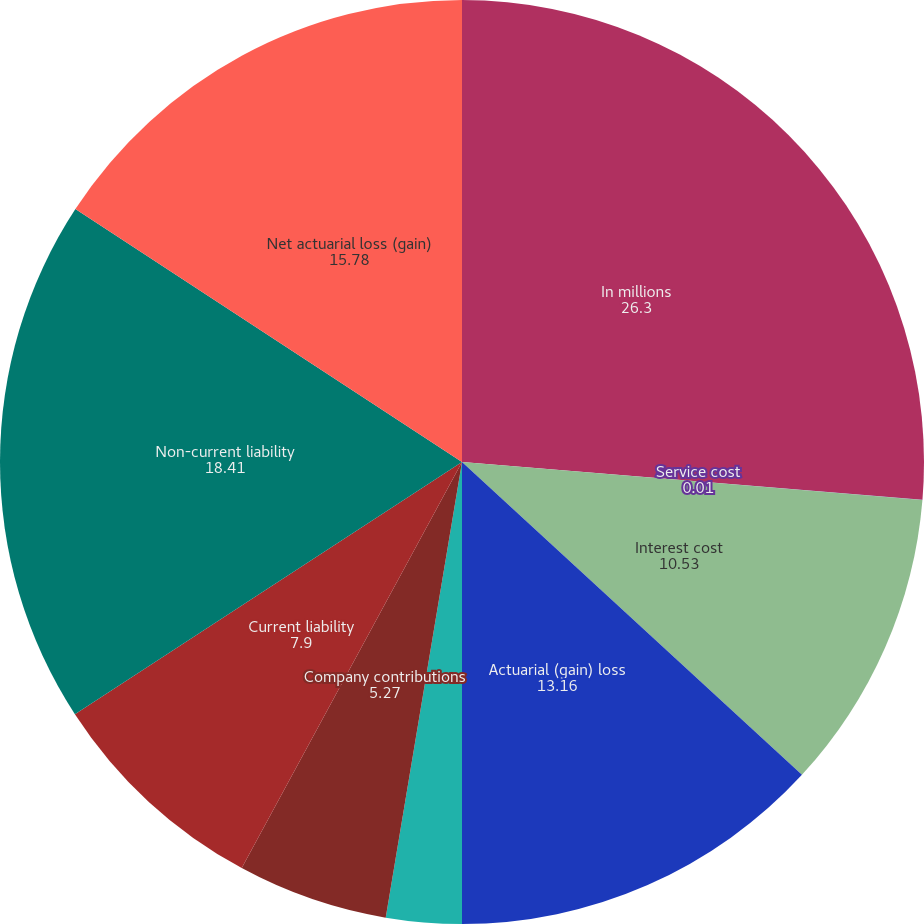<chart> <loc_0><loc_0><loc_500><loc_500><pie_chart><fcel>In millions<fcel>Service cost<fcel>Interest cost<fcel>Actuarial (gain) loss<fcel>Benefits paid<fcel>Company contributions<fcel>Current liability<fcel>Non-current liability<fcel>Net actuarial loss (gain)<nl><fcel>26.3%<fcel>0.01%<fcel>10.53%<fcel>13.16%<fcel>2.64%<fcel>5.27%<fcel>7.9%<fcel>18.41%<fcel>15.78%<nl></chart> 